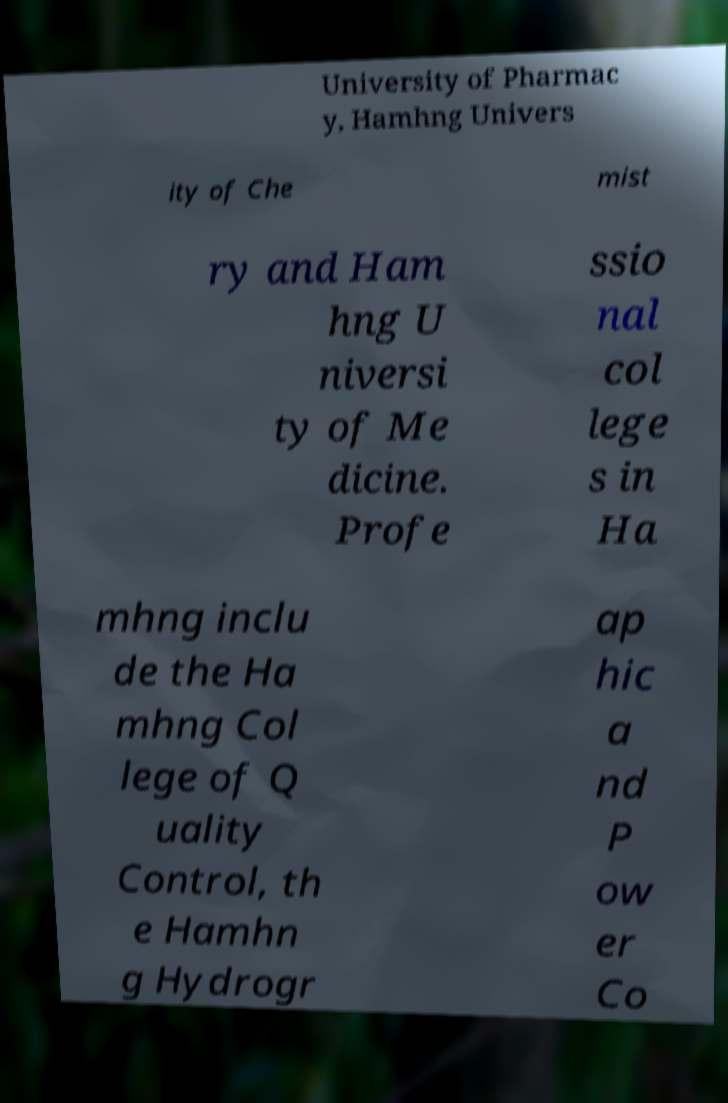Can you accurately transcribe the text from the provided image for me? University of Pharmac y, Hamhng Univers ity of Che mist ry and Ham hng U niversi ty of Me dicine. Profe ssio nal col lege s in Ha mhng inclu de the Ha mhng Col lege of Q uality Control, th e Hamhn g Hydrogr ap hic a nd P ow er Co 